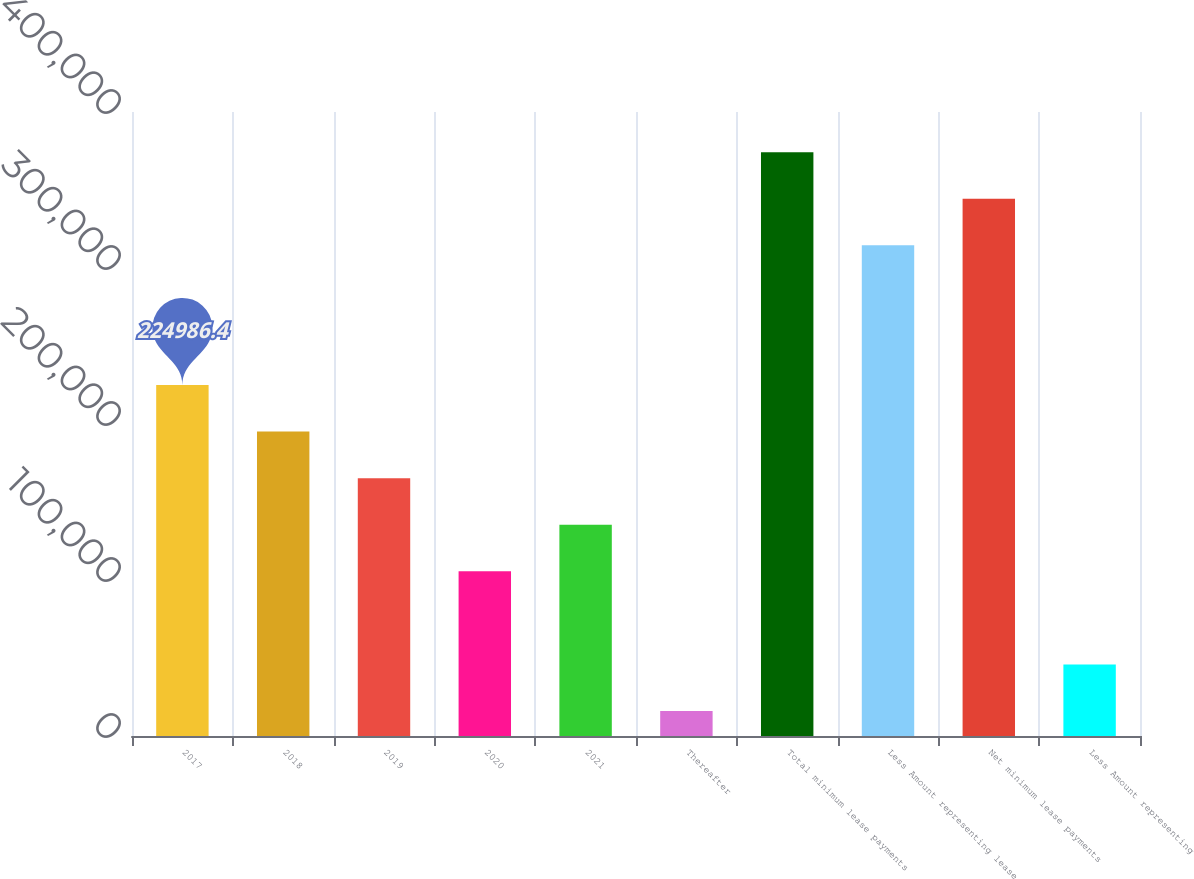Convert chart to OTSL. <chart><loc_0><loc_0><loc_500><loc_500><bar_chart><fcel>2017<fcel>2018<fcel>2019<fcel>2020<fcel>2021<fcel>Thereafter<fcel>Total minimum lease payments<fcel>Less Amount representing lease<fcel>Net minimum lease payments<fcel>Less Amount representing<nl><fcel>224986<fcel>195131<fcel>165276<fcel>105566<fcel>135421<fcel>16000<fcel>374262<fcel>314552<fcel>344407<fcel>45855.2<nl></chart> 